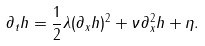Convert formula to latex. <formula><loc_0><loc_0><loc_500><loc_500>\partial _ { t } h = \frac { 1 } { 2 } \lambda ( \partial _ { x } h ) ^ { 2 } + \nu \partial _ { x } ^ { 2 } h + \eta .</formula> 